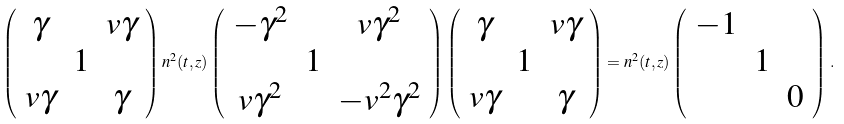<formula> <loc_0><loc_0><loc_500><loc_500>\left ( \begin{array} { c c c } \gamma & & v \gamma \\ & 1 & \\ v \gamma & & \gamma \end{array} \right ) n ^ { 2 } ( t , z ) \left ( \begin{array} { c c c } - \gamma ^ { 2 } & & v \gamma ^ { 2 } \\ & 1 & \\ v \gamma ^ { 2 } & & - v ^ { 2 } \gamma ^ { 2 } \end{array} \right ) \left ( \begin{array} { c c c } \gamma & & v \gamma \\ & 1 & \\ v \gamma & & \gamma \end{array} \right ) = n ^ { 2 } ( t , z ) \left ( \begin{array} { c c c } - 1 & & \\ & 1 & \\ & & 0 \end{array} \right ) \, .</formula> 